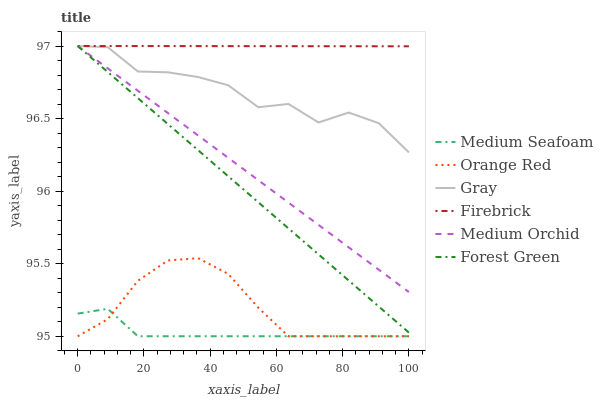Does Medium Seafoam have the minimum area under the curve?
Answer yes or no. Yes. Does Firebrick have the maximum area under the curve?
Answer yes or no. Yes. Does Medium Orchid have the minimum area under the curve?
Answer yes or no. No. Does Medium Orchid have the maximum area under the curve?
Answer yes or no. No. Is Medium Orchid the smoothest?
Answer yes or no. Yes. Is Gray the roughest?
Answer yes or no. Yes. Is Firebrick the smoothest?
Answer yes or no. No. Is Firebrick the roughest?
Answer yes or no. No. Does Orange Red have the lowest value?
Answer yes or no. Yes. Does Medium Orchid have the lowest value?
Answer yes or no. No. Does Forest Green have the highest value?
Answer yes or no. Yes. Does Orange Red have the highest value?
Answer yes or no. No. Is Orange Red less than Medium Orchid?
Answer yes or no. Yes. Is Medium Orchid greater than Orange Red?
Answer yes or no. Yes. Does Medium Orchid intersect Firebrick?
Answer yes or no. Yes. Is Medium Orchid less than Firebrick?
Answer yes or no. No. Is Medium Orchid greater than Firebrick?
Answer yes or no. No. Does Orange Red intersect Medium Orchid?
Answer yes or no. No. 